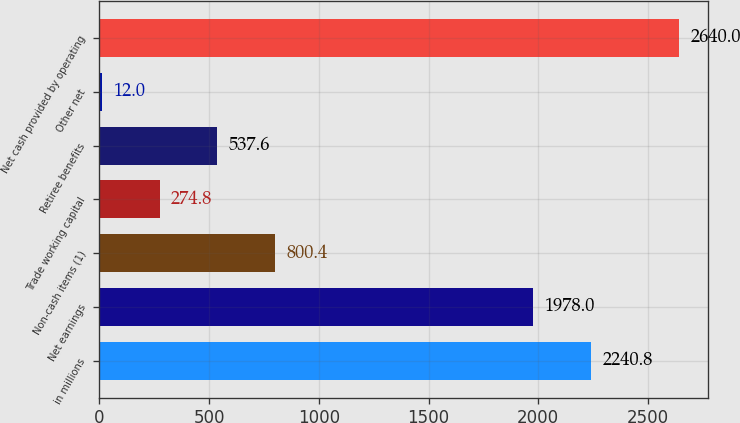Convert chart to OTSL. <chart><loc_0><loc_0><loc_500><loc_500><bar_chart><fcel>in millions<fcel>Net earnings<fcel>Non-cash items (1)<fcel>Trade working capital<fcel>Retiree benefits<fcel>Other net<fcel>Net cash provided by operating<nl><fcel>2240.8<fcel>1978<fcel>800.4<fcel>274.8<fcel>537.6<fcel>12<fcel>2640<nl></chart> 